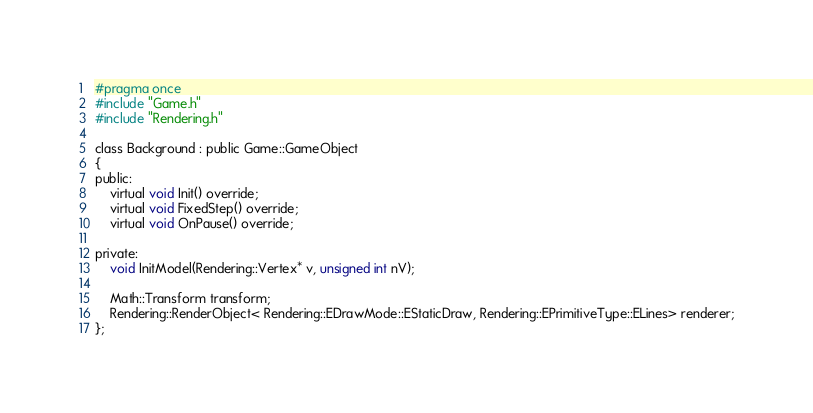Convert code to text. <code><loc_0><loc_0><loc_500><loc_500><_C_>#pragma once
#include "Game.h"
#include "Rendering.h"

class Background : public Game::GameObject
{
public:
	virtual void Init() override;
	virtual void FixedStep() override;
	virtual void OnPause() override;

private:
	void InitModel(Rendering::Vertex* v, unsigned int nV);

	Math::Transform transform;
	Rendering::RenderObject< Rendering::EDrawMode::EStaticDraw, Rendering::EPrimitiveType::ELines> renderer;
};

</code> 